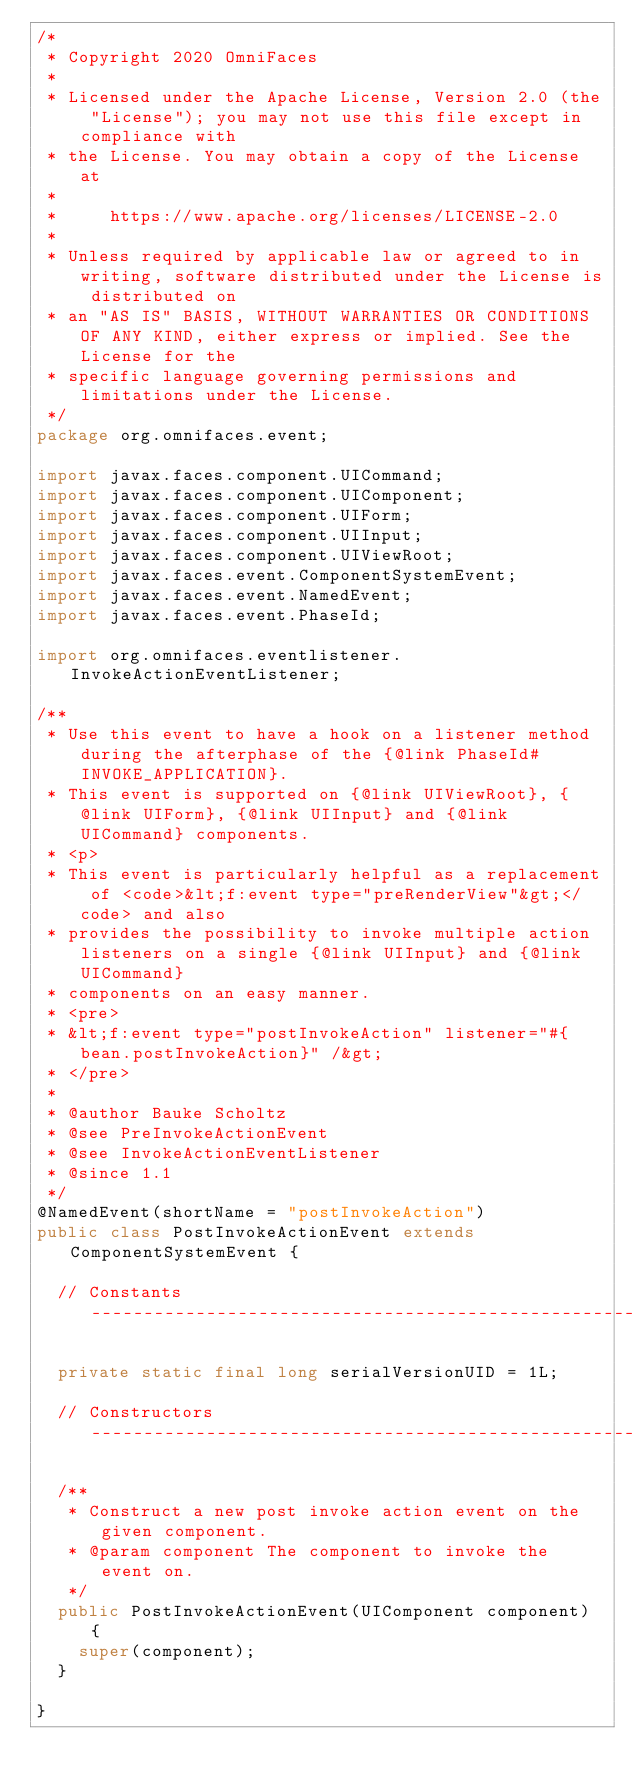<code> <loc_0><loc_0><loc_500><loc_500><_Java_>/*
 * Copyright 2020 OmniFaces
 *
 * Licensed under the Apache License, Version 2.0 (the "License"); you may not use this file except in compliance with
 * the License. You may obtain a copy of the License at
 *
 *     https://www.apache.org/licenses/LICENSE-2.0
 *
 * Unless required by applicable law or agreed to in writing, software distributed under the License is distributed on
 * an "AS IS" BASIS, WITHOUT WARRANTIES OR CONDITIONS OF ANY KIND, either express or implied. See the License for the
 * specific language governing permissions and limitations under the License.
 */
package org.omnifaces.event;

import javax.faces.component.UICommand;
import javax.faces.component.UIComponent;
import javax.faces.component.UIForm;
import javax.faces.component.UIInput;
import javax.faces.component.UIViewRoot;
import javax.faces.event.ComponentSystemEvent;
import javax.faces.event.NamedEvent;
import javax.faces.event.PhaseId;

import org.omnifaces.eventlistener.InvokeActionEventListener;

/**
 * Use this event to have a hook on a listener method during the afterphase of the {@link PhaseId#INVOKE_APPLICATION}.
 * This event is supported on {@link UIViewRoot}, {@link UIForm}, {@link UIInput} and {@link UICommand} components.
 * <p>
 * This event is particularly helpful as a replacement of <code>&lt;f:event type="preRenderView"&gt;</code> and also
 * provides the possibility to invoke multiple action listeners on a single {@link UIInput} and {@link UICommand}
 * components on an easy manner.
 * <pre>
 * &lt;f:event type="postInvokeAction" listener="#{bean.postInvokeAction}" /&gt;
 * </pre>
 *
 * @author Bauke Scholtz
 * @see PreInvokeActionEvent
 * @see InvokeActionEventListener
 * @since 1.1
 */
@NamedEvent(shortName = "postInvokeAction")
public class PostInvokeActionEvent extends ComponentSystemEvent {

	// Constants ------------------------------------------------------------------------------------------------------

	private static final long serialVersionUID = 1L;

	// Constructors ---------------------------------------------------------------------------------------------------

	/**
	 * Construct a new post invoke action event on the given component.
	 * @param component The component to invoke the event on.
	 */
	public PostInvokeActionEvent(UIComponent component) {
		super(component);
	}

}</code> 